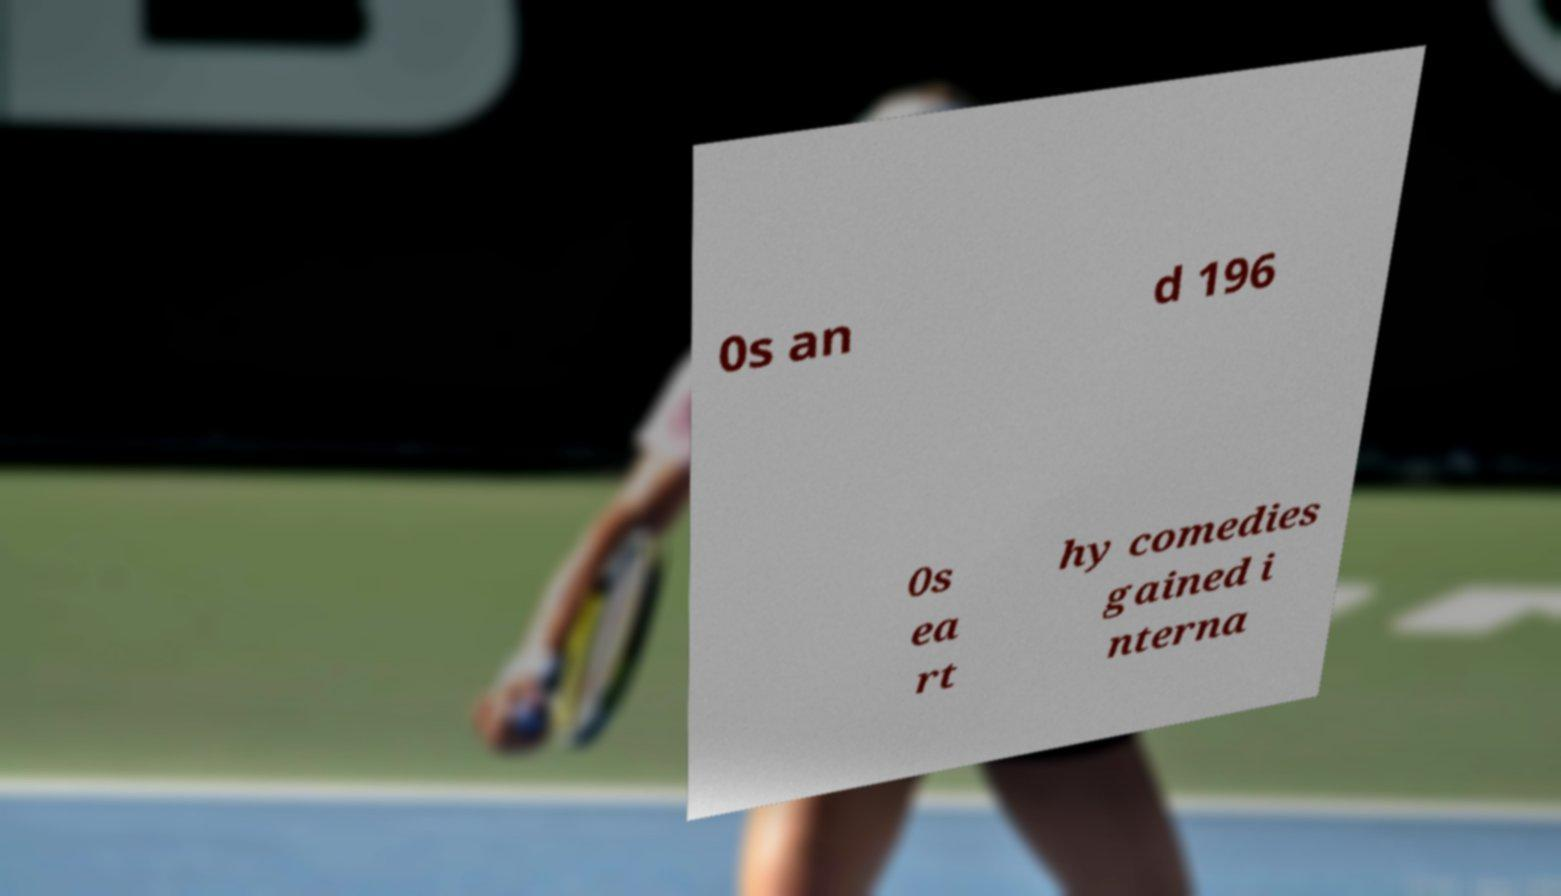For documentation purposes, I need the text within this image transcribed. Could you provide that? 0s an d 196 0s ea rt hy comedies gained i nterna 